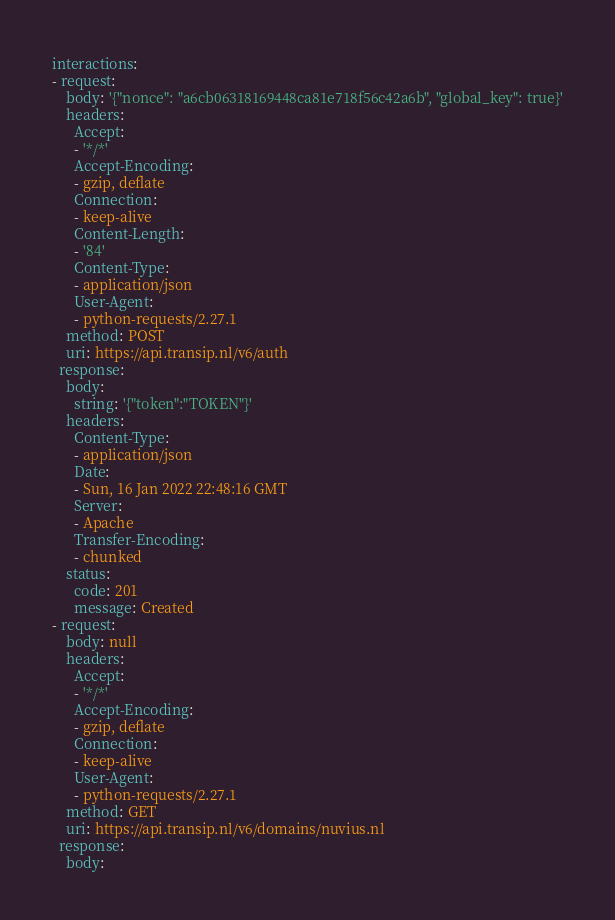Convert code to text. <code><loc_0><loc_0><loc_500><loc_500><_YAML_>interactions:
- request:
    body: '{"nonce": "a6cb06318169448ca81e718f56c42a6b", "global_key": true}'
    headers:
      Accept:
      - '*/*'
      Accept-Encoding:
      - gzip, deflate
      Connection:
      - keep-alive
      Content-Length:
      - '84'
      Content-Type:
      - application/json
      User-Agent:
      - python-requests/2.27.1
    method: POST
    uri: https://api.transip.nl/v6/auth
  response:
    body:
      string: '{"token":"TOKEN"}'
    headers:
      Content-Type:
      - application/json
      Date:
      - Sun, 16 Jan 2022 22:48:16 GMT
      Server:
      - Apache
      Transfer-Encoding:
      - chunked
    status:
      code: 201
      message: Created
- request:
    body: null
    headers:
      Accept:
      - '*/*'
      Accept-Encoding:
      - gzip, deflate
      Connection:
      - keep-alive
      User-Agent:
      - python-requests/2.27.1
    method: GET
    uri: https://api.transip.nl/v6/domains/nuvius.nl
  response:
    body:</code> 